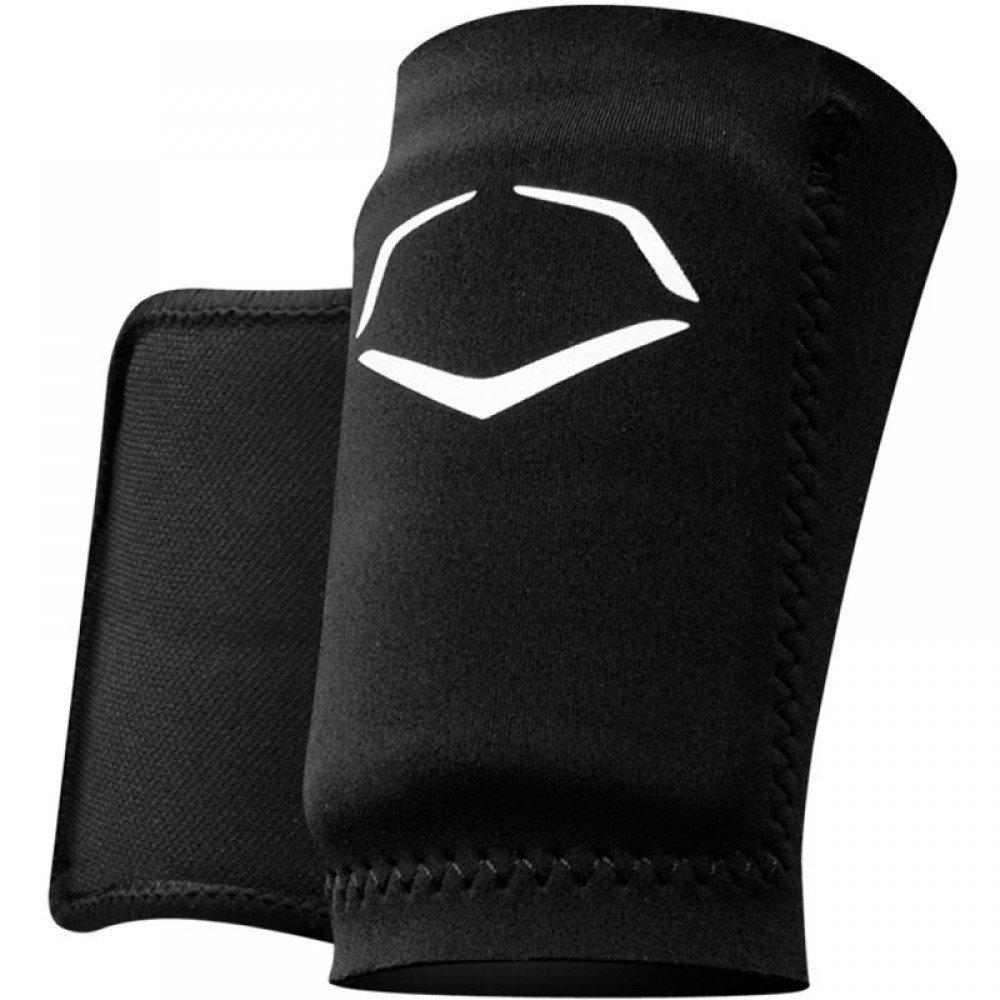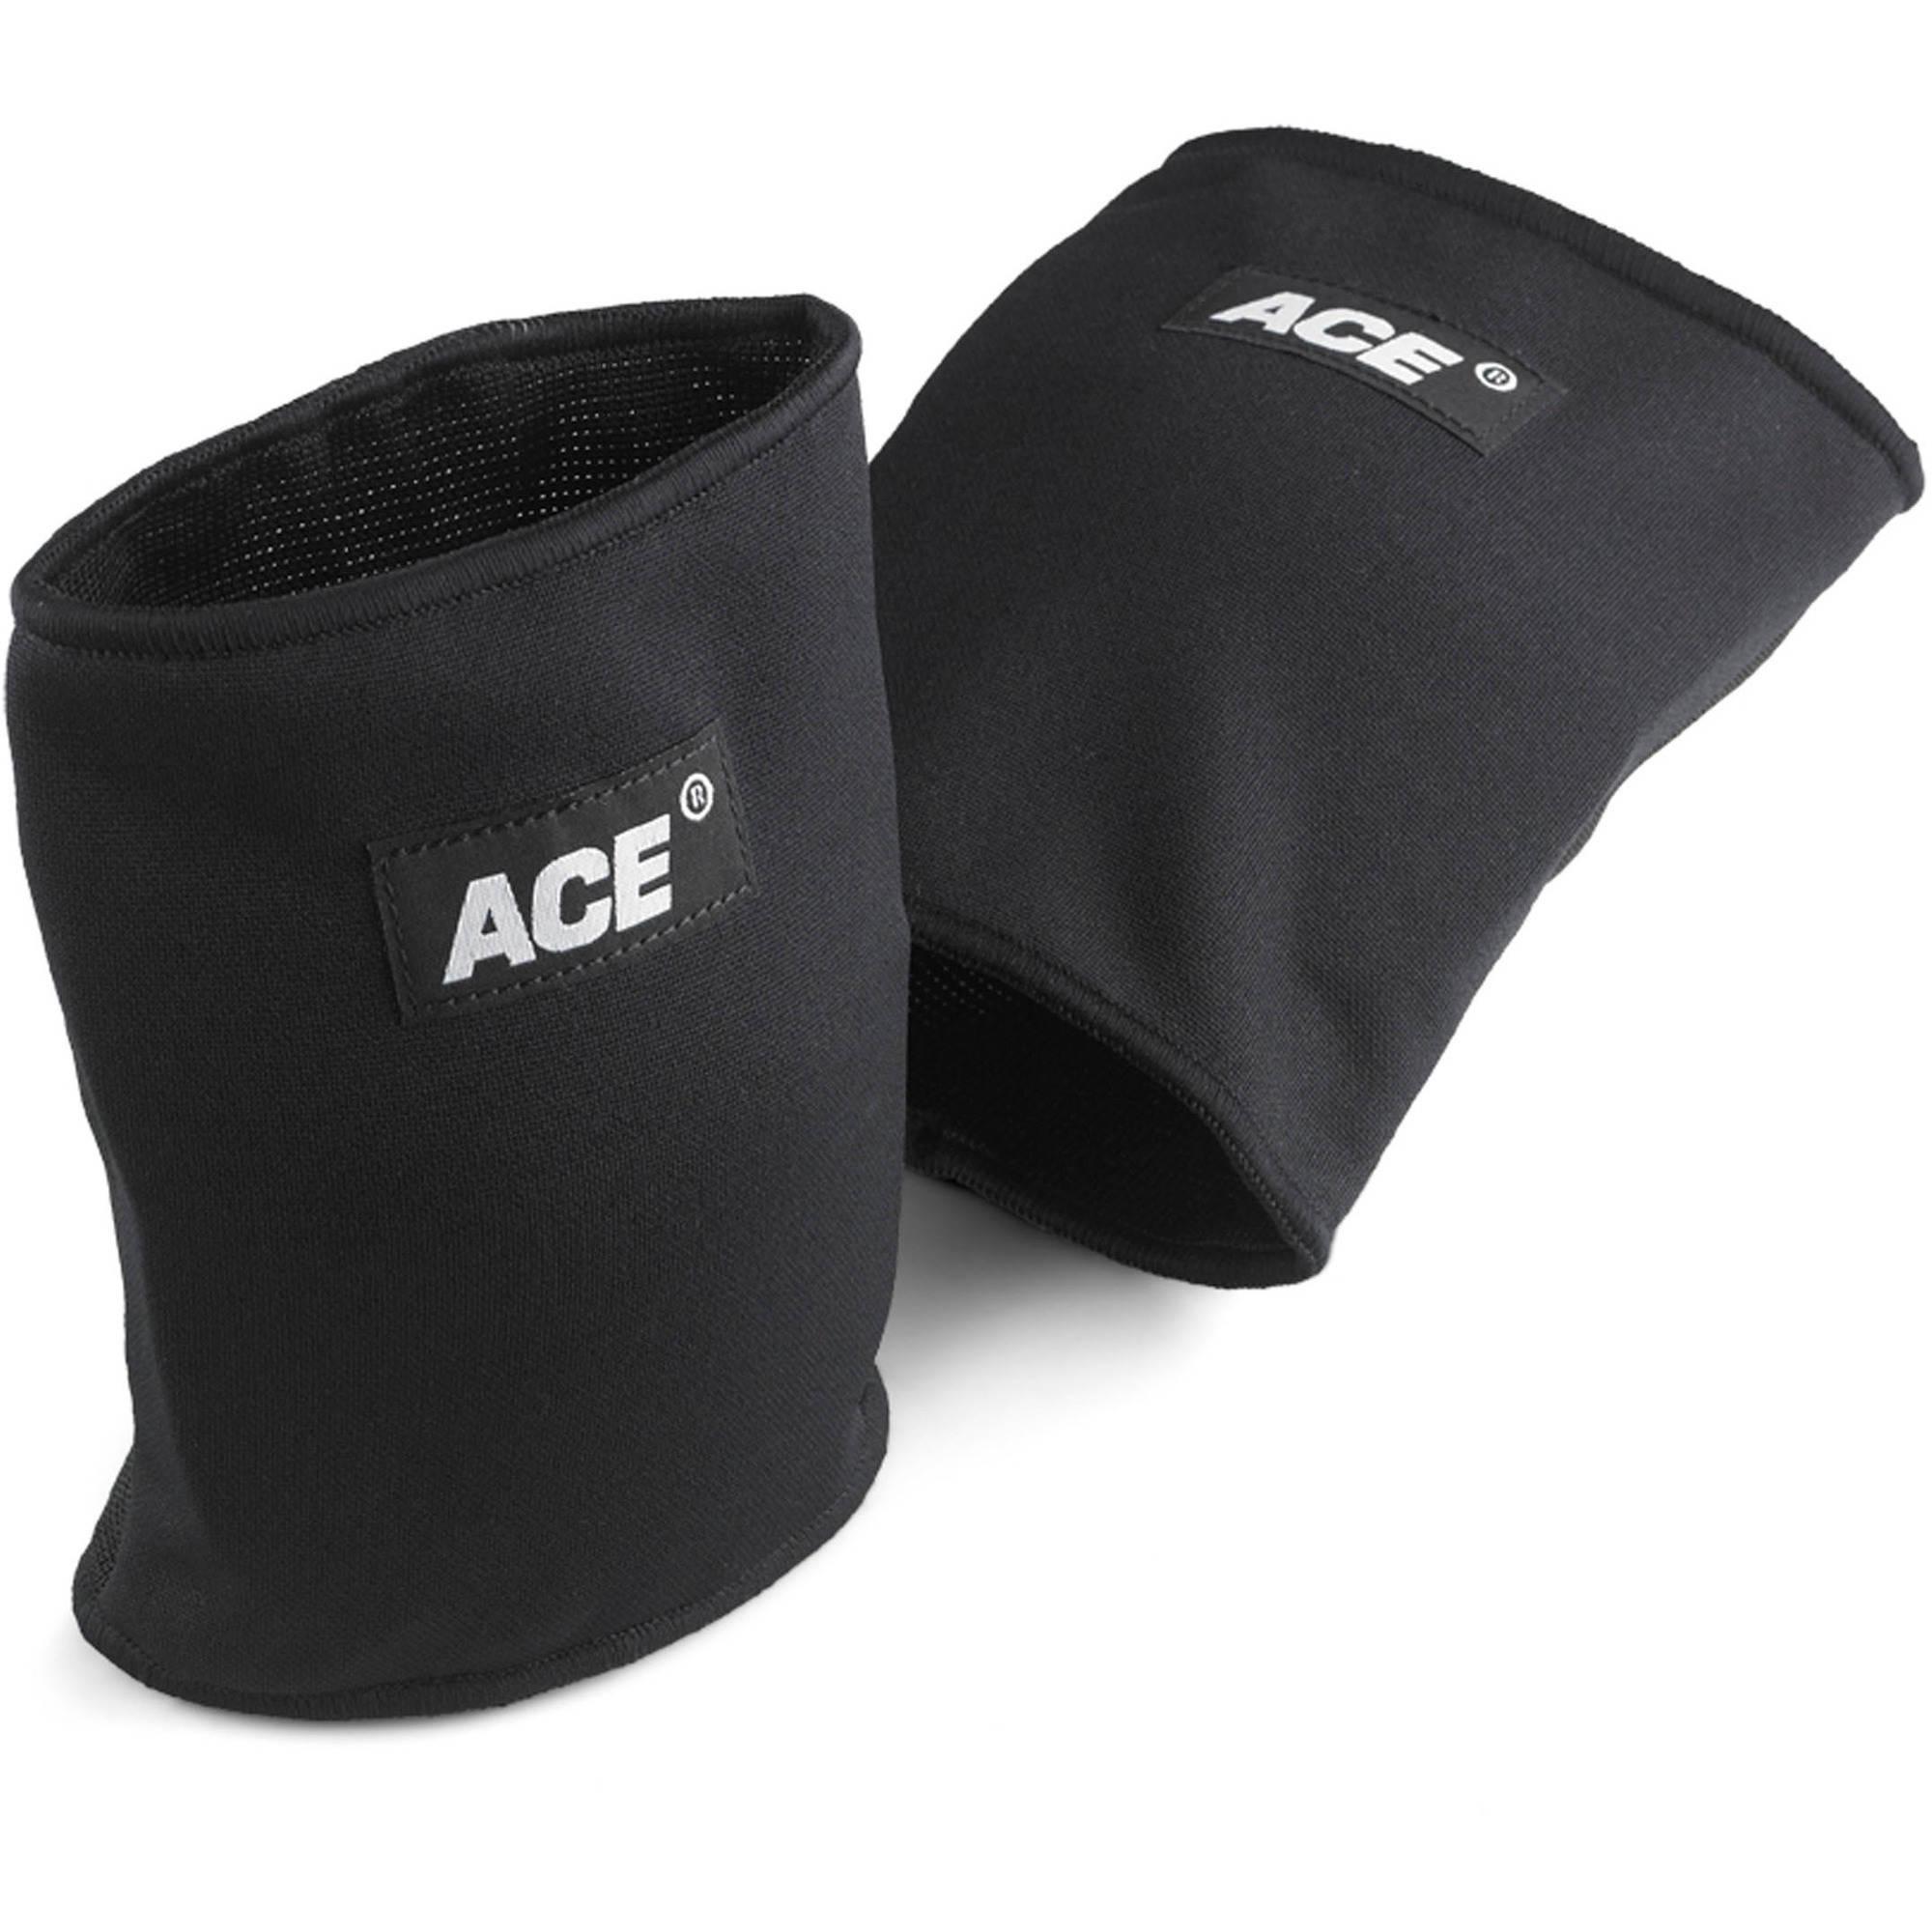The first image is the image on the left, the second image is the image on the right. Analyze the images presented: Is the assertion "At least one white knee brace with black logo is shown in one image." valid? Answer yes or no. No. The first image is the image on the left, the second image is the image on the right. Analyze the images presented: Is the assertion "There are both black and white knee pads" valid? Answer yes or no. No. 